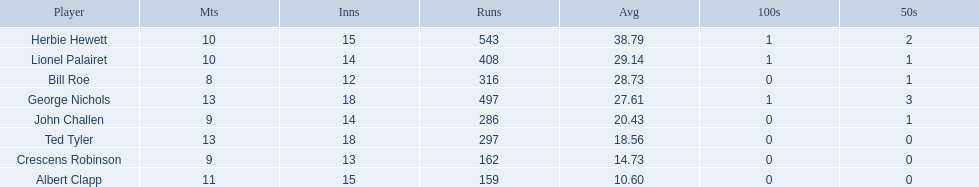Who are all of the players? Herbie Hewett, Lionel Palairet, Bill Roe, George Nichols, John Challen, Ted Tyler, Crescens Robinson, Albert Clapp. How many innings did they play in? 15, 14, 12, 18, 14, 18, 13, 15. Which player was in fewer than 13 innings? Bill Roe. I'm looking to parse the entire table for insights. Could you assist me with that? {'header': ['Player', 'Mts', 'Inns', 'Runs', 'Avg', '100s', '50s'], 'rows': [['Herbie Hewett', '10', '15', '543', '38.79', '1', '2'], ['Lionel Palairet', '10', '14', '408', '29.14', '1', '1'], ['Bill Roe', '8', '12', '316', '28.73', '0', '1'], ['George Nichols', '13', '18', '497', '27.61', '1', '3'], ['John Challen', '9', '14', '286', '20.43', '0', '1'], ['Ted Tyler', '13', '18', '297', '18.56', '0', '0'], ['Crescens Robinson', '9', '13', '162', '14.73', '0', '0'], ['Albert Clapp', '11', '15', '159', '10.60', '0', '0']]} 